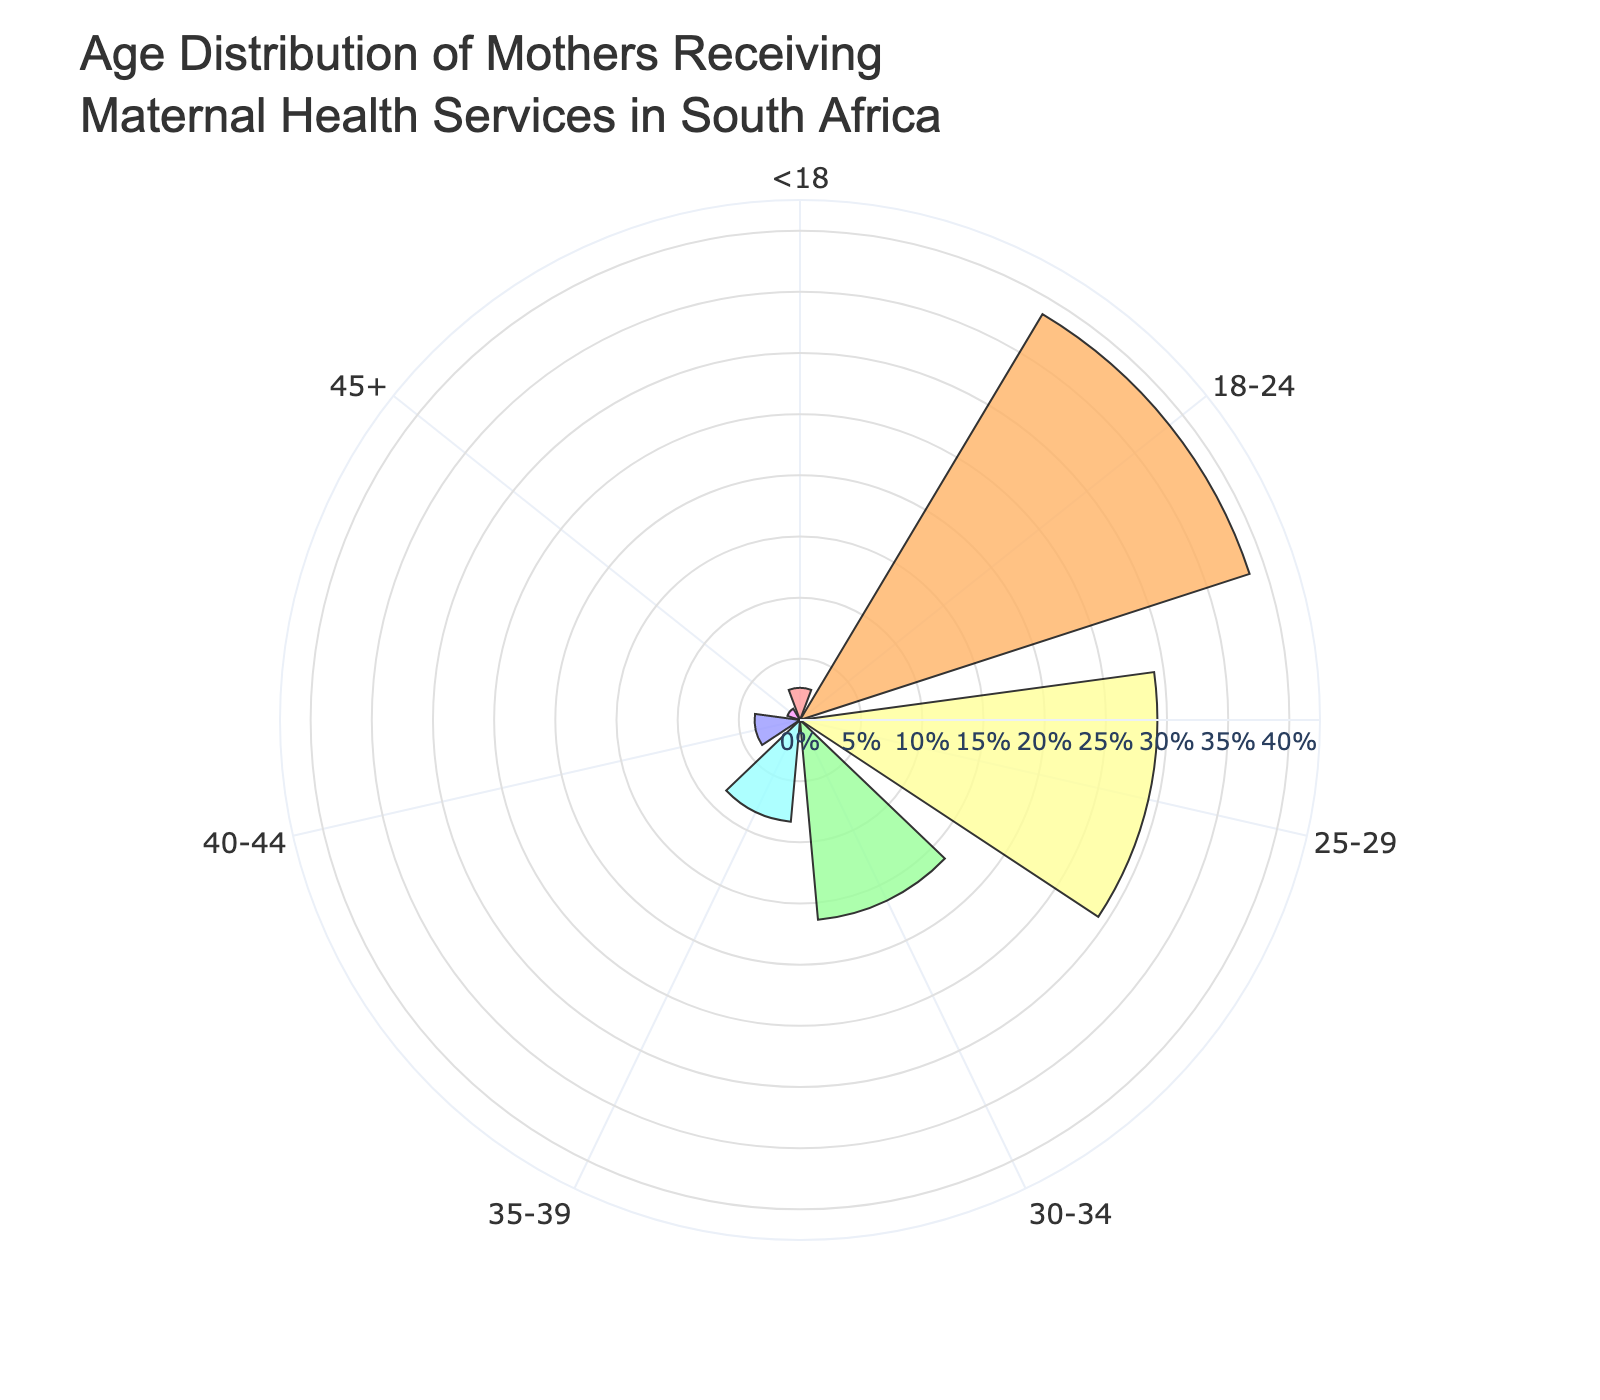What is the title of the chart? The title is placed at the top and describes the figure in large, bold text
Answer: Age Distribution of Mothers Receiving Maternal Health Services in South Africa How many age groups are represented in the chart? By looking at the different segments in the rose chart, you can count the distinct age groups
Answer: 7 Which age group has the highest percentage? The segment with the largest radial length indicates the highest percentage
Answer: 18-24 What is the percentage of mothers aged below 18? Read the percentage label closest to the <18 age group segment
Answer: 5.8% Compare the percentage of mothers aged 30-34 to those aged 35-39. Which group has a higher percentage? Look at the radial lengths and percentage labels of both segments; 30-34 should be longer
Answer: 30-34 What is the sum of the percentages of mothers aged 25-29 and 30-34? Add the percentages provided in the segments for 25-29 and 30-34
Answer: 20.8% Calculate the difference in percentages between the youngest (<18) and the oldest (45+) age groups. Subtract the percentage for 45+ from the percentage for <18
Answer: 5.3% Which age group shows the lowest percentage? Identify the segment with the shortest radial length that represents the lowest percentage
Answer: 45+ How do the percentages in the 35-39 and 40-44 age groups compare? Compare the radial lengths and percentage labels; note which one is larger
Answer: 35-39 is higher What trend can you observe in the distribution of mothers' ages from youngest to oldest? Observe the gradual change in radial lengths from <18 to 45+
Answer: The percentage decreases with increasing age 